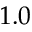Convert formula to latex. <formula><loc_0><loc_0><loc_500><loc_500>1 . 0</formula> 